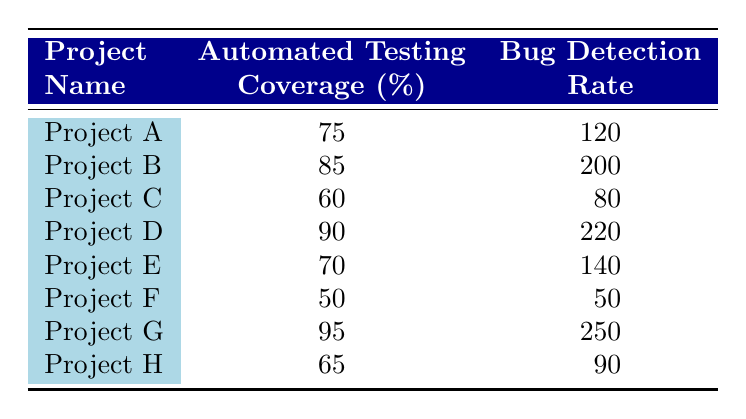What is the bug detection rate for Project C? Project C has a bug detection rate listed in the table as 80.
Answer: 80 What is the automated testing coverage percentage for Project E? The table indicates that Project E has an automated testing coverage percentage of 70.
Answer: 70 Which project has the highest bug detection rate? By scanning the "Bug Detection Rate" column, Project G has the highest value at 250.
Answer: Project G What is the average automated testing coverage percentage across all projects? To find the average, we add the coverage percentages (75 + 85 + 60 + 90 + 70 + 50 + 95 + 65 = 690) and divide by the number of projects (8). Therefore, the average is 690/8 = 86.25.
Answer: 86.25 Is it true that Project D has a higher bug detection rate than Project B? Comparing the bug detection rates, Project D has a rate of 220 while Project B has 200, so it is true.
Answer: Yes What is the difference in bug detection rates between Project A and Project F? The bug detection rate for Project A is 120 and for Project F it is 50. The difference is 120 - 50 = 70.
Answer: 70 Which project(s) have an automated testing coverage of over 80%? By looking at the "Automated Testing Coverage" column, Projects B, D, and G have percentages greater than 80 (85, 90, and 95 respectively).
Answer: Project B, Project D, Project G What is the total bug detection rate for projects with automated testing coverage below 70%? The projects with coverage below 70% are Project F (50) and Project H (90). Their total bug detection rate is 50 + 90 = 140.
Answer: 140 Is there a correlation between higher automated testing coverage and increased bug detection rates based on this data? The data suggests that as the automated testing coverage percentage increases, the bug detection rates also tend to increase, but further statistical analysis would be required to determine a true correlation.
Answer: Yes, but further analysis is needed 